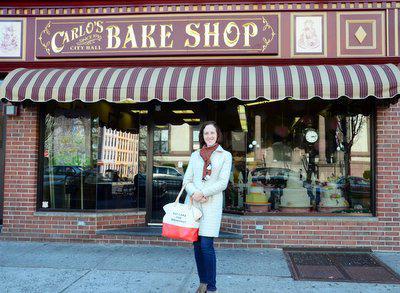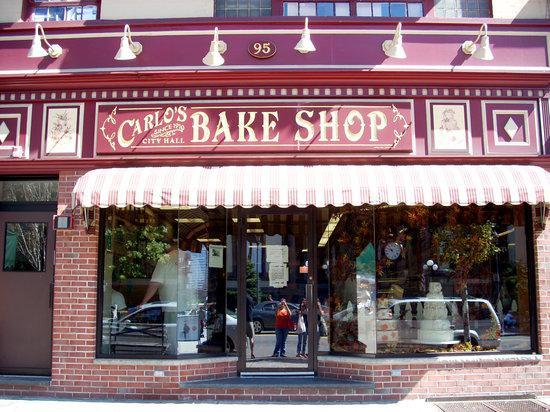The first image is the image on the left, the second image is the image on the right. Analyze the images presented: Is the assertion "There is a man with his  palms facing up." valid? Answer yes or no. No. 